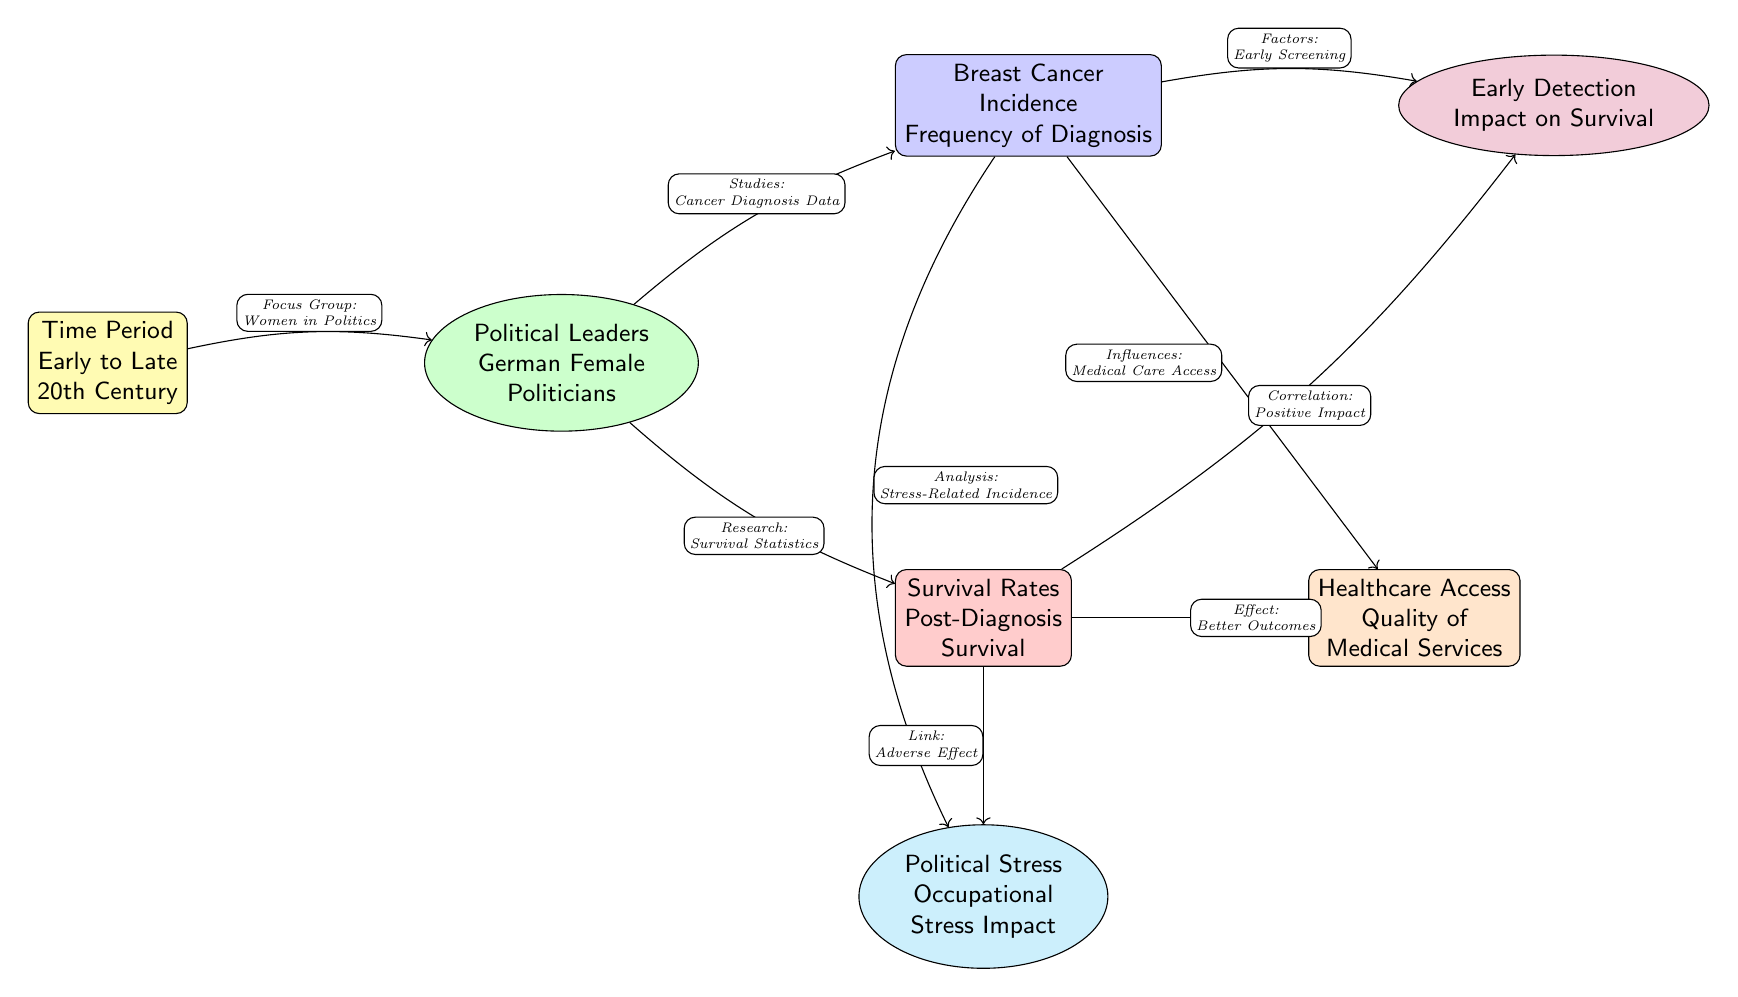What time period does the diagram cover? The diagram specifies "Early to Late 20th Century" as the time period in the first node.
Answer: Early to Late 20th Century How many main nodes are there in the diagram? By counting the highlighted nodes, there are a total of seven main nodes depicted in the diagram.
Answer: 7 What is the focus group mentioned in the diagram? The diagram illustrates that the focus group consists of "Women in Politics" as labeled on the edge leading from the first to the second node.
Answer: Women in Politics What factors influence early screening according to the diagram? The diagram connects "Breast Cancer Incidence" to "Early Detection," indicating that early screening is influenced by factors related to diagnosis frequency.
Answer: Early Screening How does breast cancer incidence relate to healthcare access? The relationship is shown through the edge labeled "Influences," bridging the "Breast Cancer Incidence" node to the "Quality of Medical Services" node, demonstrating that incidence is influenced by healthcare accessibility.
Answer: Influences What correlation is indicated between survival rates and early detection? The diagram includes an arrow from "Survival Rates" to "Early Detection," labeled "Correlation," implying a positive relationship where early detection leads to improved survival rates.
Answer: Positive Impact Which node is linked with "Occupational Stress Impact"? The diagram shows an edge from the "Survival Rates" node leading to the "Political Stress" node, indicating that this node represents the impact of occupational stress on survival.
Answer: Political Stress What type of diagram is this and what does it illustrate? This is a Biomedical Diagram that illustrates the relationships between breast cancer incidence, survival rates, and factors influencing them among female politicians throughout the 20th century.
Answer: Biomedical Diagram 